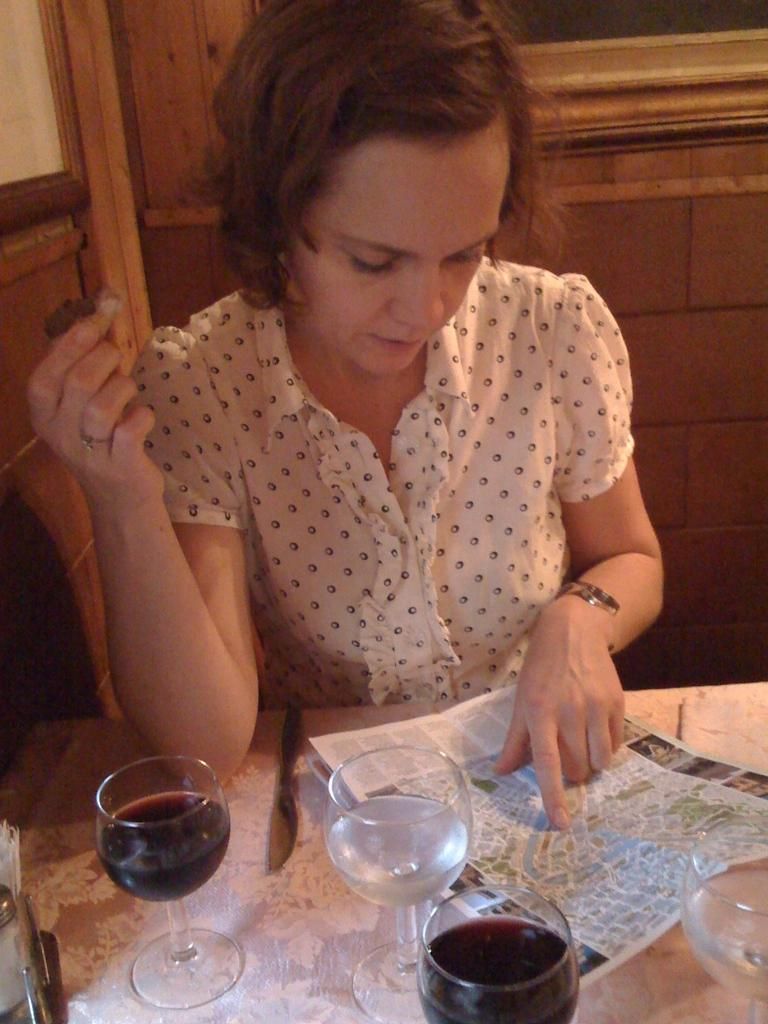What objects are on the table in the image? There are wine glasses on the table. What is the woman in the image doing? The woman is looking at a paper. Where is the paper located on the table? The paper is in the middle of the table. What type of tree can be seen growing through the locket in the image? There is no tree or locket present in the image; it only features wine glasses and a woman looking at a paper on a table. 